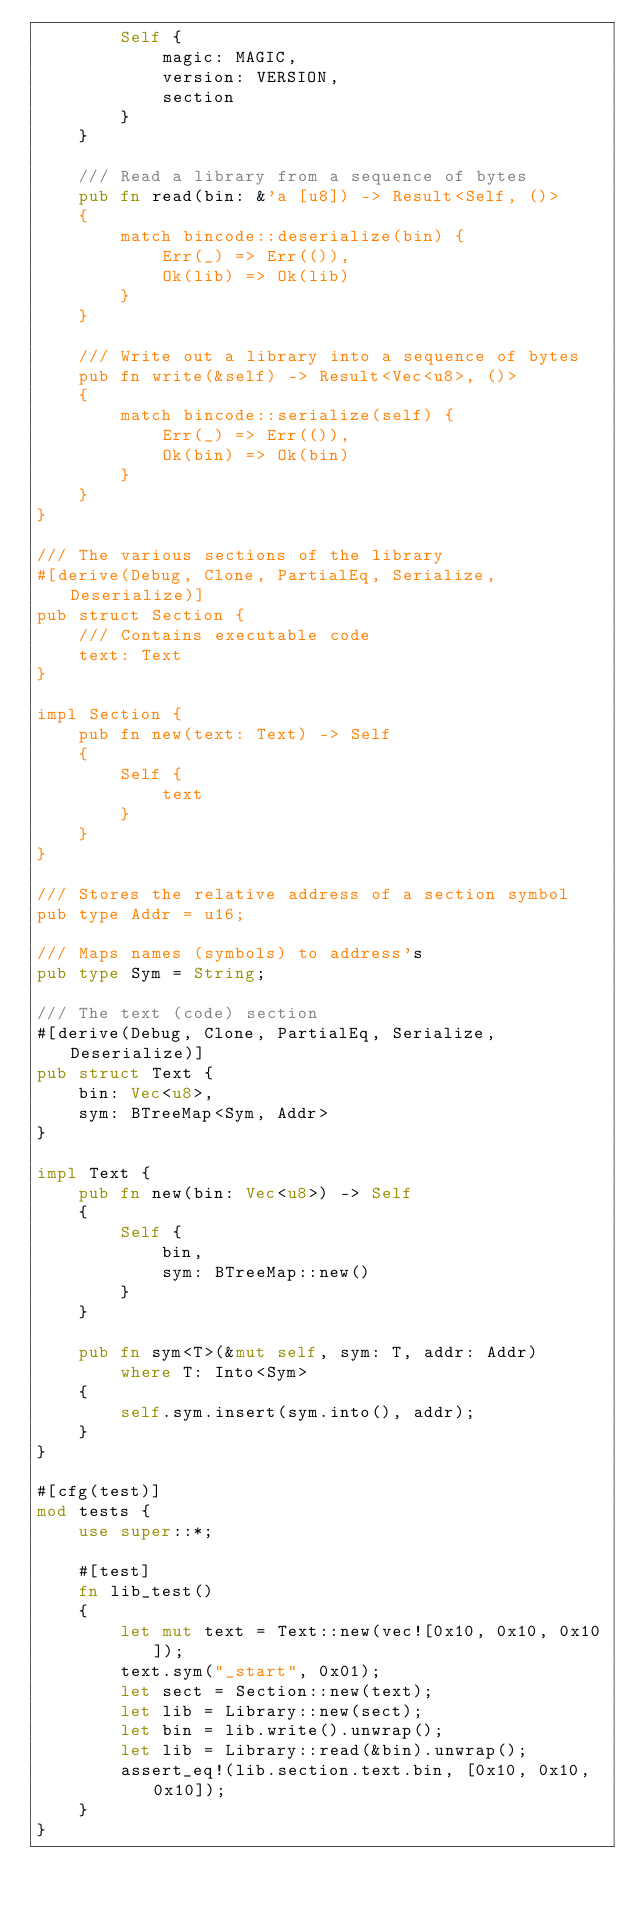<code> <loc_0><loc_0><loc_500><loc_500><_Rust_>        Self {
            magic: MAGIC,
            version: VERSION,
            section
        }
    }

    /// Read a library from a sequence of bytes
    pub fn read(bin: &'a [u8]) -> Result<Self, ()>
    {
        match bincode::deserialize(bin) {
            Err(_) => Err(()),
            Ok(lib) => Ok(lib)
        }
    }

    /// Write out a library into a sequence of bytes
    pub fn write(&self) -> Result<Vec<u8>, ()>
    {
        match bincode::serialize(self) {
            Err(_) => Err(()),
            Ok(bin) => Ok(bin)
        }
    }
}

/// The various sections of the library
#[derive(Debug, Clone, PartialEq, Serialize, Deserialize)]
pub struct Section {
    /// Contains executable code
    text: Text
}

impl Section {
    pub fn new(text: Text) -> Self
    {
        Self {
            text
        }
    }
}

/// Stores the relative address of a section symbol
pub type Addr = u16;

/// Maps names (symbols) to address's
pub type Sym = String;

/// The text (code) section
#[derive(Debug, Clone, PartialEq, Serialize, Deserialize)]
pub struct Text {
    bin: Vec<u8>,
    sym: BTreeMap<Sym, Addr>
}

impl Text {
    pub fn new(bin: Vec<u8>) -> Self
    {
        Self {
            bin,
            sym: BTreeMap::new()
        }
    }

    pub fn sym<T>(&mut self, sym: T, addr: Addr)
        where T: Into<Sym>
    {
        self.sym.insert(sym.into(), addr);
    }
}

#[cfg(test)]
mod tests {
    use super::*;

    #[test]
    fn lib_test()
    {
        let mut text = Text::new(vec![0x10, 0x10, 0x10]);
        text.sym("_start", 0x01);
        let sect = Section::new(text);
        let lib = Library::new(sect);
        let bin = lib.write().unwrap();
        let lib = Library::read(&bin).unwrap();
        assert_eq!(lib.section.text.bin, [0x10, 0x10, 0x10]);
    }
}
</code> 